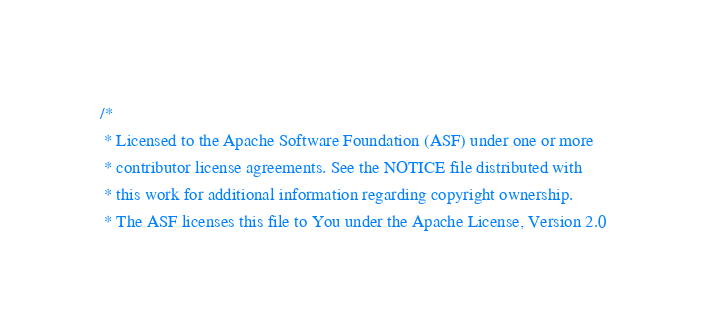<code> <loc_0><loc_0><loc_500><loc_500><_Scala_>/*
 * Licensed to the Apache Software Foundation (ASF) under one or more
 * contributor license agreements. See the NOTICE file distributed with
 * this work for additional information regarding copyright ownership.
 * The ASF licenses this file to You under the Apache License, Version 2.0</code> 